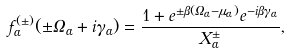<formula> <loc_0><loc_0><loc_500><loc_500>f _ { \alpha } ^ { ( \pm ) } ( \pm \Omega _ { \alpha } + i \gamma _ { \alpha } ) = \frac { 1 + e ^ { \pm \beta ( \Omega _ { \alpha } - \mu _ { \alpha } ) } e ^ { - i \beta \gamma _ { \alpha } } } { X ^ { \pm } _ { \alpha } } ,</formula> 